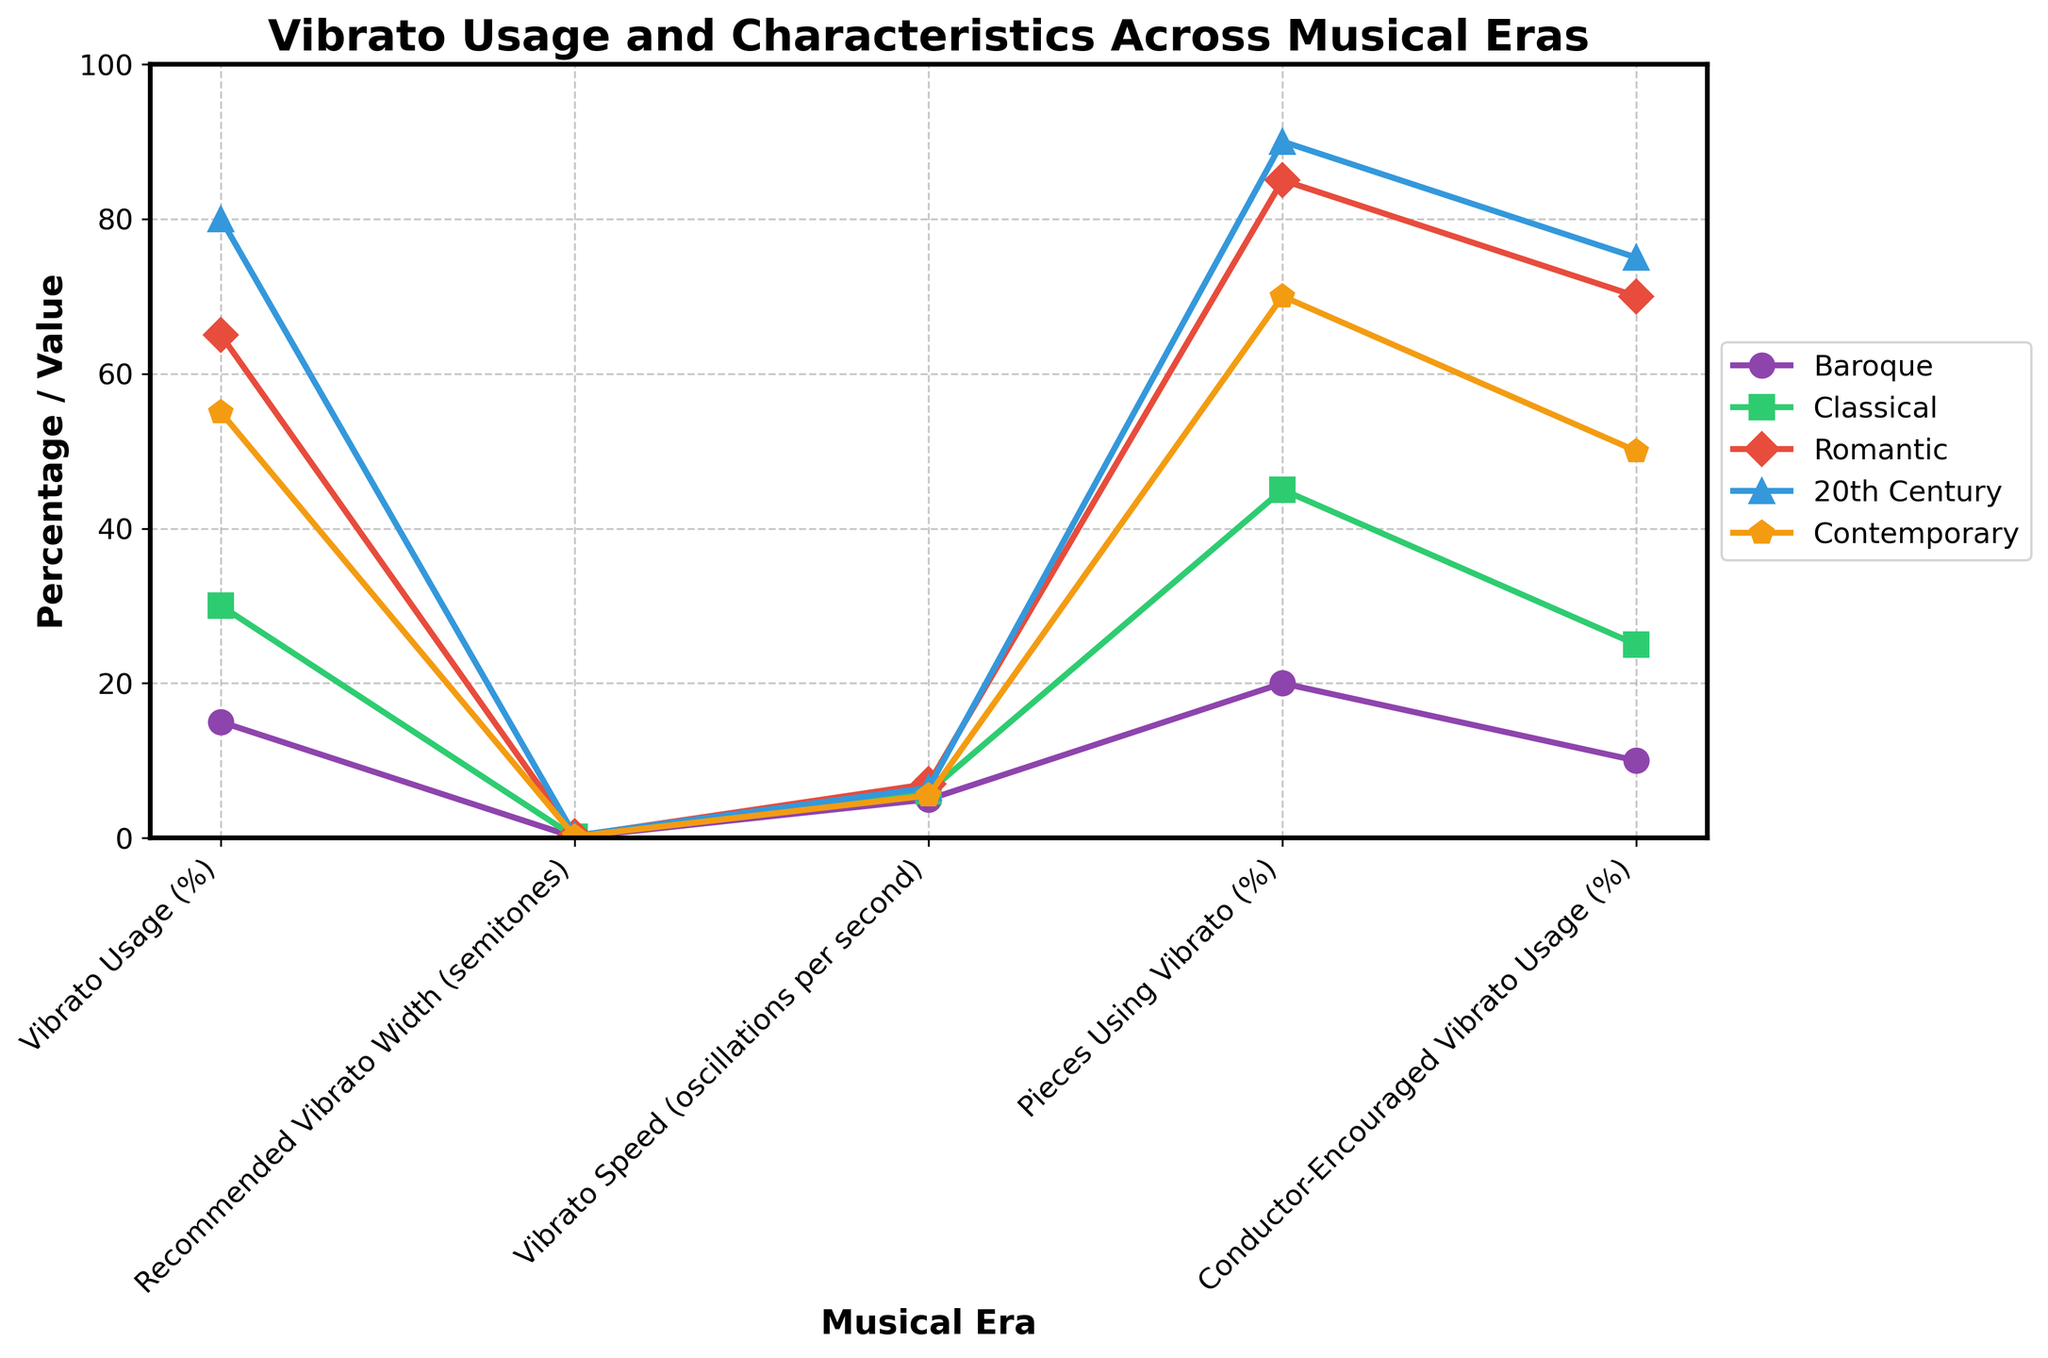What's the percentage difference in Vibrato Usage between the Baroque and 20th Century eras? To calculate the percentage difference between the Baroque and 20th Century eras for Vibrato Usage, subtract the Baroque value from the 20th Century value, then divide by the Baroque value and multiply by 100. The calculation is ((80 - 15) / 15) * 100 = 433.33%.
Answer: 433.33% In which era did the Recommended Vibrato Width increase the most compared to the previous era? Compare the differences in Recommended Vibrato Width between each consecutive era. From Baroque to Classical: 0.15 - 0.1 = 0.05. From Classical to Romantic: 0.25 - 0.15 = 0.10. From Romantic to 20th Century: 0.3 - 0.25 = 0.05. From 20th Century to Contemporary: 0.2 - 0.3 = -0.1. The greatest increase was from Classical to Romantic.
Answer: Romantic Which musical era has the highest average usage across all metrics? Calculate the average for each era by summing up the values for all metrics and dividing by the number of metrics (5). Baroque: (15 + 0.1 + 5 + 20 + 10) / 5 = 10.02. Classical: (30 + 0.15 + 6 + 45 + 25) / 5 = 21.03. Romantic: (65 + 0.25 + 7 + 85 + 70) / 5 = 45.85. 20th Century: (80 + 0.3 + 6.5 + 90 + 75) / 5 = 50.76. Contemporary: (55 + 0.2 + 5.5 + 70 + 50) / 5 = 36.14. The 20th Century era has the highest average usage.
Answer: 20th Century What is the difference in Vibrato Speed between the Romantic and Contemporary eras? Subtract the Vibrato Speed of the Contemporary era from the Vibrato Speed of the Romantic era. The Vibrato Speed for the Romantic era is 7 oscillations per second, and for the Contemporary era, it is 5.5 oscillations per second. The calculation is 7 - 5.5 = 1.5 oscillations per second.
Answer: 1.5 By how much did the Conductor-Encouraged Vibrato Usage (%) in the Classical era increase compared to the Baroque era? Subtract the Conductor-Encouraged Vibrato Usage of the Baroque era from the Classical era. For the Baroque era, it's 10%, and for the Classical era, it's 25%. The calculation is 25 - 10 = 15%.
Answer: 15% Which era has the smallest difference between the actual Vibrato Usage (%) and the Pieces Using Vibrato (%)? Calculate the difference between Vibrato Usage (%) and Pieces Using Vibrato (%) for each era and find the smallest difference. Baroque: 20 - 15 = 5%. Classical: 45 - 30 = 15%. Romantic: 85 - 65 = 20%. 20th Century: 90 - 80 = 10%. Contemporary: 70 - 55 = 15%. The smallest difference is in the Baroque era.
Answer: Baroque What is the average Vibrato Speed across all eras? Sum the Vibrato Speed values for all eras and divide by the number of eras (5). The calculation is (5 + 6 + 7 + 6.5 + 5.5) / 5 = 6.
Answer: 6 Between which two consecutive eras did the Pieces Using Vibrato (%) increase the most? Calculate the differences in Pieces Using Vibrato (%) between each consecutive era. From Baroque to Classical: 45 - 20 = 25%. From Classical to Romantic: 85 - 45 = 40%. From Romantic to 20th Century: 90 - 85 = 5%. From 20th Century to Contemporary: 70 - 90 = -20%. The greatest increase was from Classical to Romantic.
Answer: Classical to Romantic 